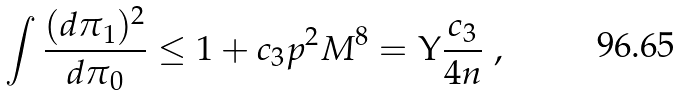<formula> <loc_0><loc_0><loc_500><loc_500>\int \frac { ( d \pi _ { 1 } ) ^ { 2 } } { d \pi _ { 0 } } \leq 1 + c _ { 3 } p ^ { 2 } M ^ { 8 } = \Upsilon \frac { c _ { 3 } } { 4 n } \ ,</formula> 